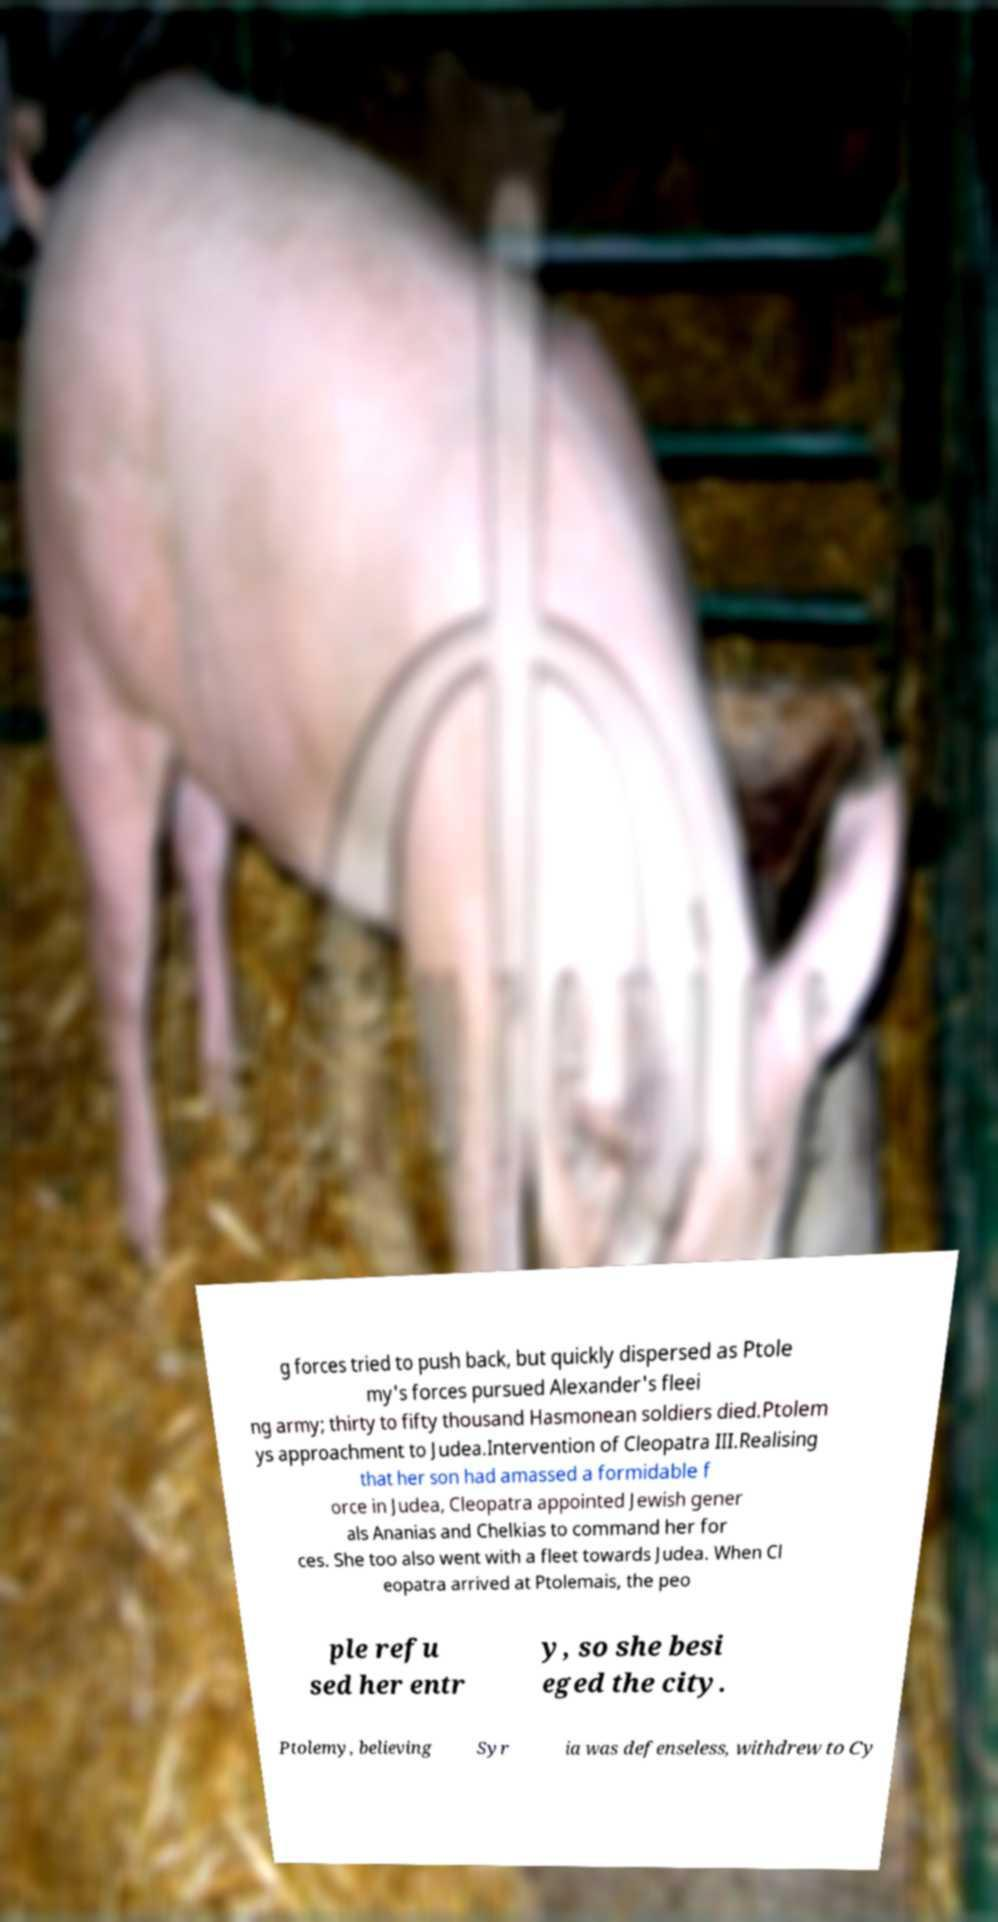Could you extract and type out the text from this image? g forces tried to push back, but quickly dispersed as Ptole my's forces pursued Alexander's fleei ng army; thirty to fifty thousand Hasmonean soldiers died.Ptolem ys approachment to Judea.Intervention of Cleopatra III.Realising that her son had amassed a formidable f orce in Judea, Cleopatra appointed Jewish gener als Ananias and Chelkias to command her for ces. She too also went with a fleet towards Judea. When Cl eopatra arrived at Ptolemais, the peo ple refu sed her entr y, so she besi eged the city. Ptolemy, believing Syr ia was defenseless, withdrew to Cy 